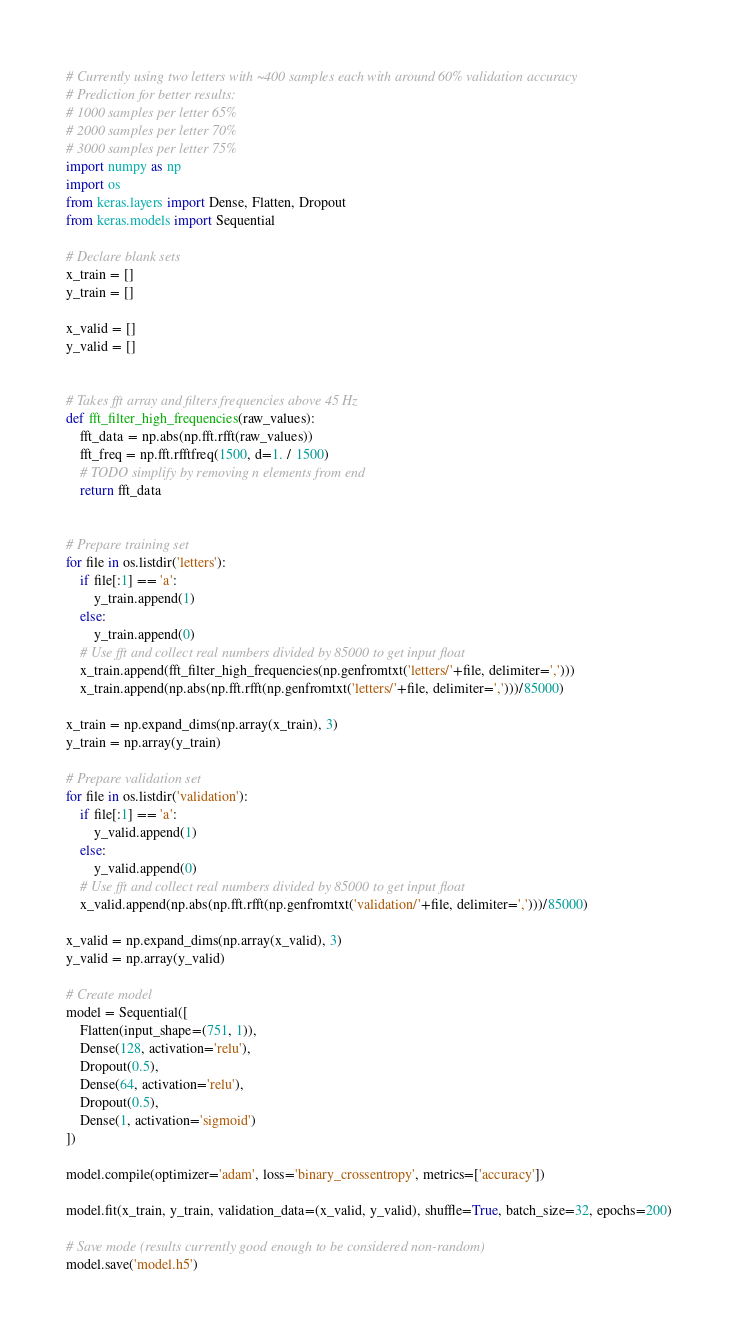Convert code to text. <code><loc_0><loc_0><loc_500><loc_500><_Python_># Currently using two letters with ~400 samples each with around 60% validation accuracy
# Prediction for better results:
# 1000 samples per letter 65%
# 2000 samples per letter 70%
# 3000 samples per letter 75%
import numpy as np
import os
from keras.layers import Dense, Flatten, Dropout
from keras.models import Sequential

# Declare blank sets
x_train = []
y_train = []

x_valid = []
y_valid = []


# Takes fft array and filters frequencies above 45 Hz
def fft_filter_high_frequencies(raw_values):
    fft_data = np.abs(np.fft.rfft(raw_values))
    fft_freq = np.fft.rfftfreq(1500, d=1. / 1500)
    # TODO simplify by removing n elements from end
    return fft_data


# Prepare training set
for file in os.listdir('letters'):
    if file[:1] == 'a':
        y_train.append(1)
    else:
        y_train.append(0)
    # Use fft and collect real numbers divided by 85000 to get input float
    x_train.append(fft_filter_high_frequencies(np.genfromtxt('letters/'+file, delimiter=',')))
    x_train.append(np.abs(np.fft.rfft(np.genfromtxt('letters/'+file, delimiter=',')))/85000)

x_train = np.expand_dims(np.array(x_train), 3)
y_train = np.array(y_train)

# Prepare validation set
for file in os.listdir('validation'):
    if file[:1] == 'a':
        y_valid.append(1)
    else:
        y_valid.append(0)
    # Use fft and collect real numbers divided by 85000 to get input float
    x_valid.append(np.abs(np.fft.rfft(np.genfromtxt('validation/'+file, delimiter=',')))/85000)

x_valid = np.expand_dims(np.array(x_valid), 3)
y_valid = np.array(y_valid)

# Create model
model = Sequential([
    Flatten(input_shape=(751, 1)),
    Dense(128, activation='relu'),
    Dropout(0.5),
    Dense(64, activation='relu'),
    Dropout(0.5),
    Dense(1, activation='sigmoid')
])

model.compile(optimizer='adam', loss='binary_crossentropy', metrics=['accuracy'])

model.fit(x_train, y_train, validation_data=(x_valid, y_valid), shuffle=True, batch_size=32, epochs=200)

# Save mode (results currently good enough to be considered non-random)
model.save('model.h5')
</code> 